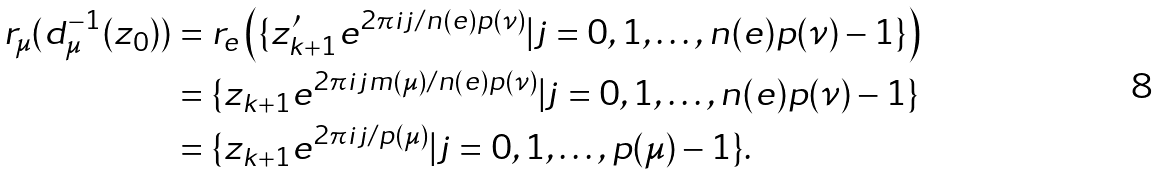Convert formula to latex. <formula><loc_0><loc_0><loc_500><loc_500>r _ { \mu } ( d _ { \mu } ^ { - 1 } ( z _ { 0 } ) ) & = r _ { e } \left ( \{ z _ { k + 1 } ^ { \prime } e ^ { 2 \pi i j / n ( e ) p ( \nu ) } | j = 0 , 1 , \dots , n ( e ) p ( \nu ) - 1 \} \right ) \\ & = \{ z _ { k + 1 } e ^ { 2 \pi i j m ( \mu ) / n ( e ) p ( \nu ) } | j = 0 , 1 , \dots , n ( e ) p ( \nu ) - 1 \} \\ & = \{ z _ { k + 1 } e ^ { 2 \pi i j / p ( \mu ) } | j = 0 , 1 , \dots , p ( \mu ) - 1 \} .</formula> 